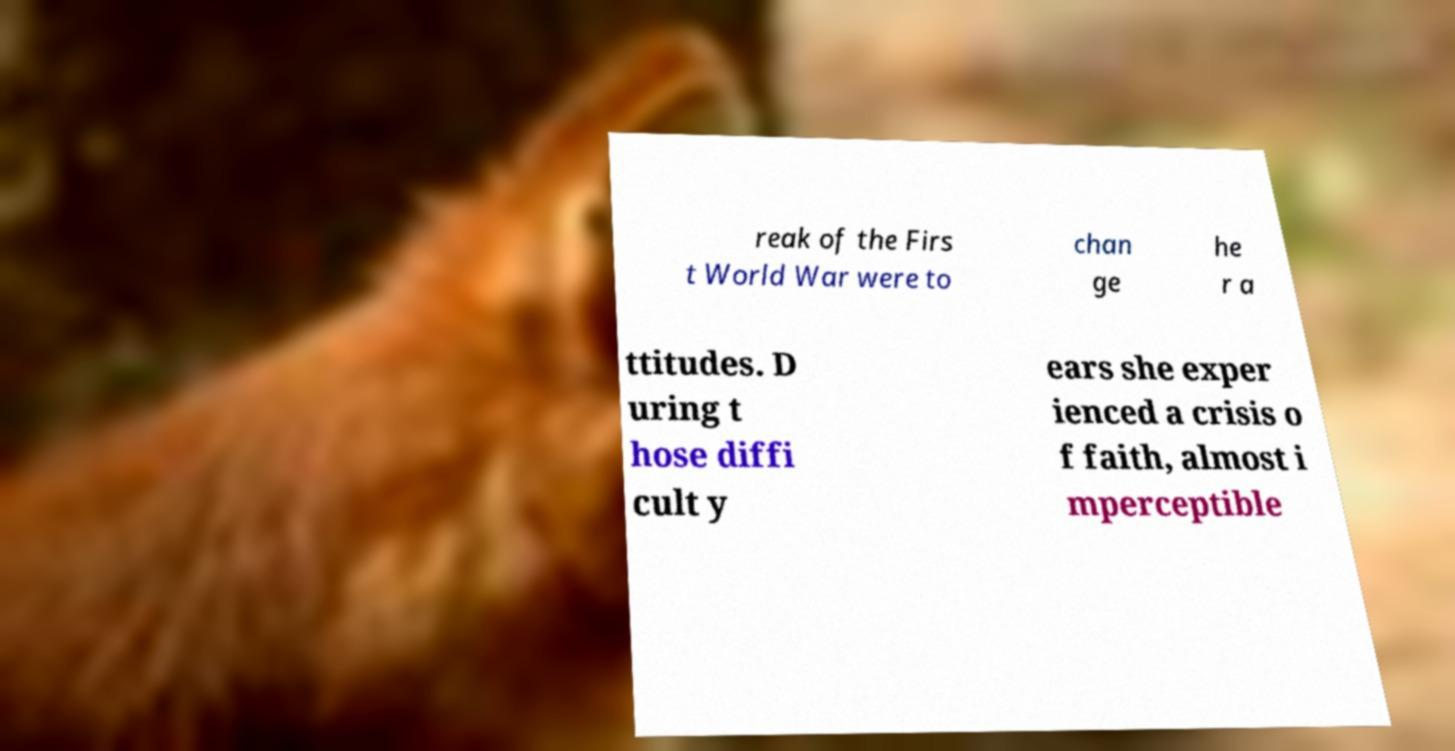Can you accurately transcribe the text from the provided image for me? reak of the Firs t World War were to chan ge he r a ttitudes. D uring t hose diffi cult y ears she exper ienced a crisis o f faith, almost i mperceptible 